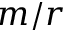<formula> <loc_0><loc_0><loc_500><loc_500>m / r</formula> 